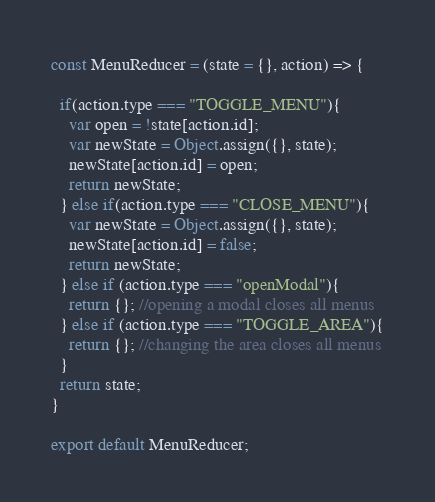<code> <loc_0><loc_0><loc_500><loc_500><_JavaScript_>const MenuReducer = (state = {}, action) => {

  if(action.type === "TOGGLE_MENU"){
    var open = !state[action.id];
    var newState = Object.assign({}, state);
    newState[action.id] = open;
    return newState;
  } else if(action.type === "CLOSE_MENU"){
    var newState = Object.assign({}, state);
    newState[action.id] = false;
    return newState;
  } else if (action.type === "openModal"){
    return {}; //opening a modal closes all menus
  } else if (action.type === "TOGGLE_AREA"){
    return {}; //changing the area closes all menus
  }
  return state;
}

export default MenuReducer;
</code> 